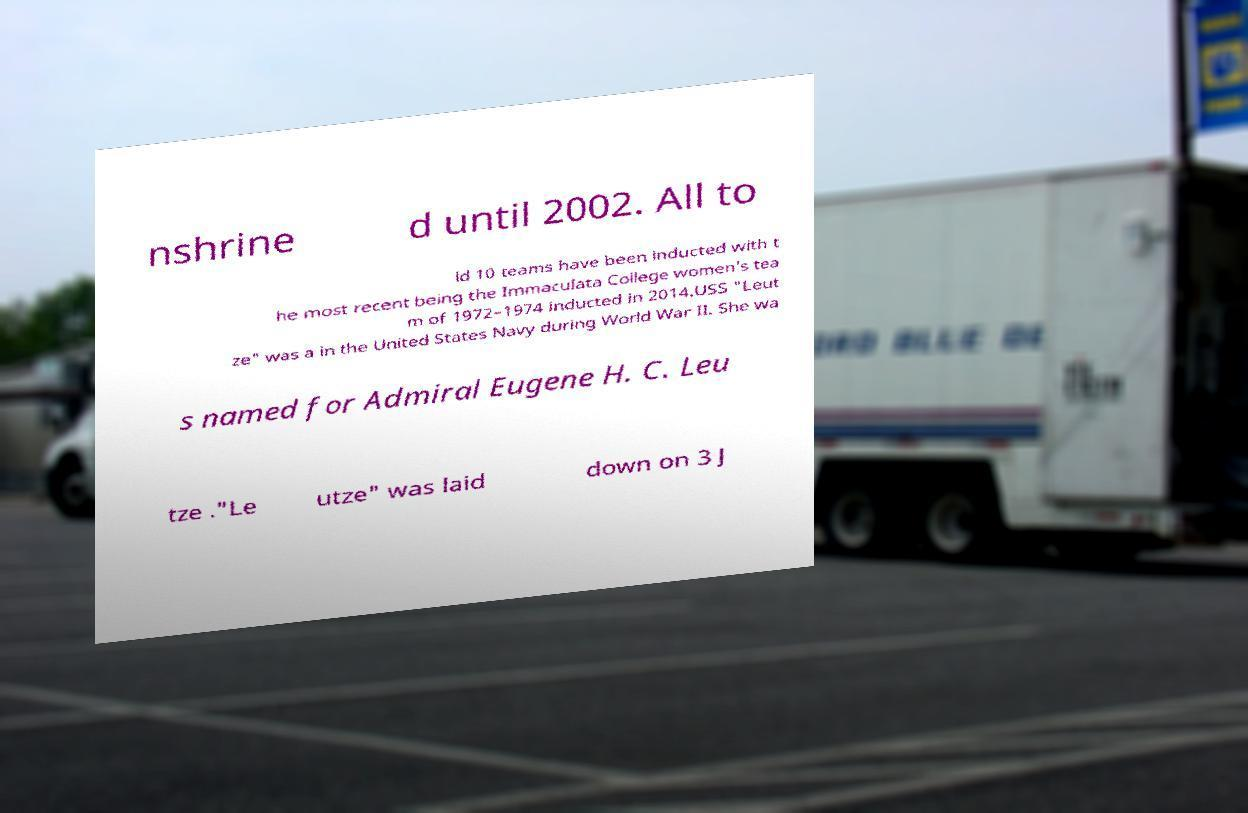Can you read and provide the text displayed in the image?This photo seems to have some interesting text. Can you extract and type it out for me? nshrine d until 2002. All to ld 10 teams have been inducted with t he most recent being the Immaculata College women's tea m of 1972–1974 inducted in 2014.USS "Leut ze" was a in the United States Navy during World War II. She wa s named for Admiral Eugene H. C. Leu tze ."Le utze" was laid down on 3 J 